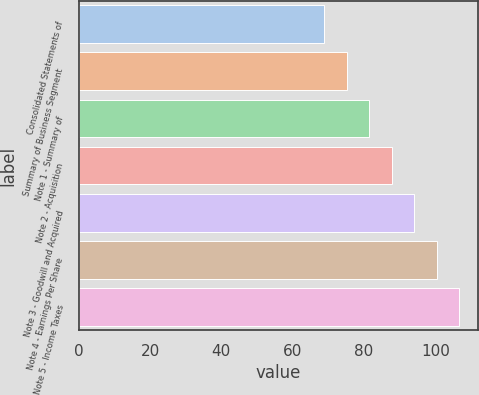Convert chart. <chart><loc_0><loc_0><loc_500><loc_500><bar_chart><fcel>Consolidated Statements of<fcel>Summary of Business Segment<fcel>Note 1 - Summary of<fcel>Note 2 - Acquisition<fcel>Note 3 - Goodwill and Acquired<fcel>Note 4 - Earnings Per Share<fcel>Note 5 - Income Taxes<nl><fcel>68.9<fcel>75.2<fcel>81.5<fcel>87.8<fcel>94.1<fcel>100.4<fcel>106.7<nl></chart> 